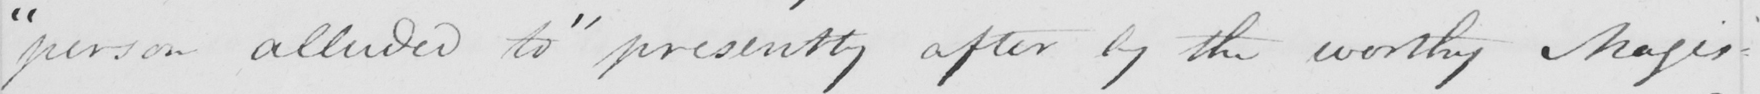Can you tell me what this handwritten text says? " person alluded to "  presently after by the worthy Magis- 